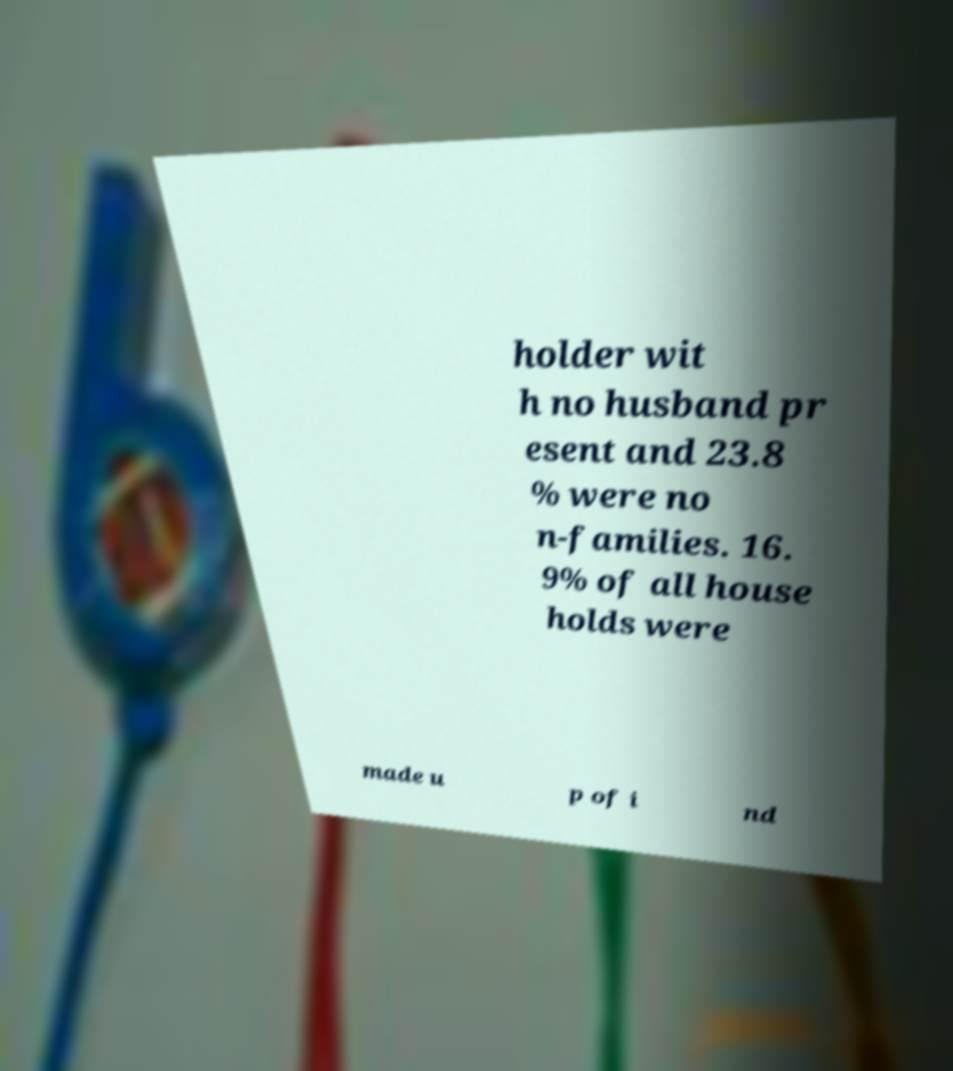Please identify and transcribe the text found in this image. holder wit h no husband pr esent and 23.8 % were no n-families. 16. 9% of all house holds were made u p of i nd 